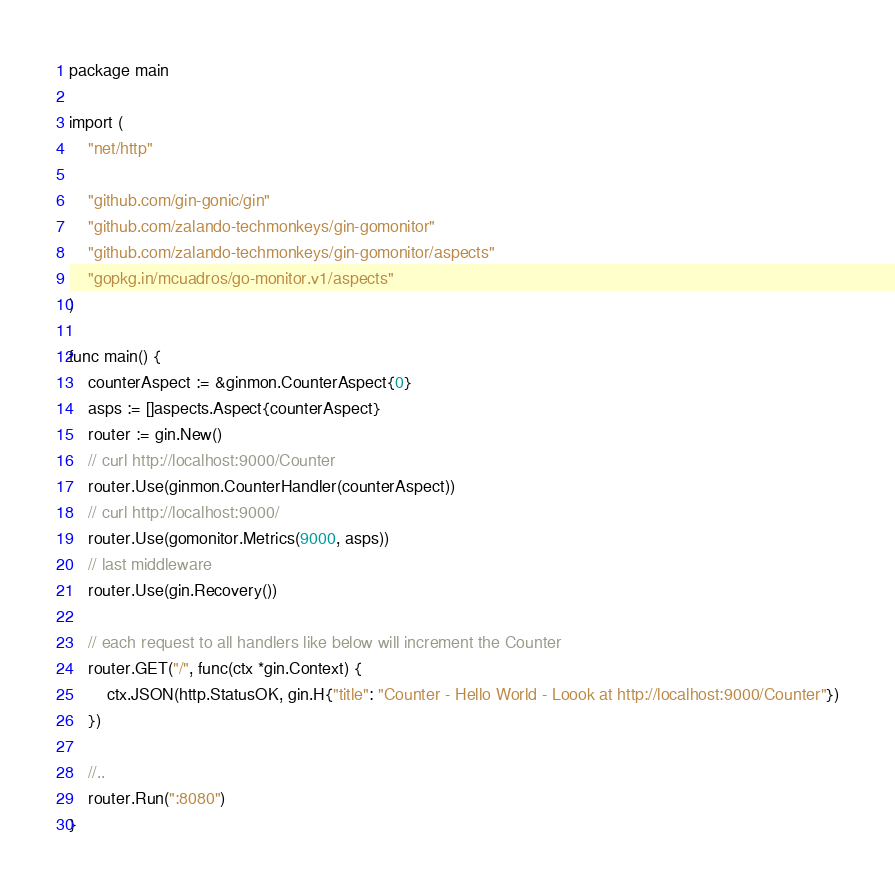Convert code to text. <code><loc_0><loc_0><loc_500><loc_500><_Go_>package main

import (
	"net/http"

	"github.com/gin-gonic/gin"
	"github.com/zalando-techmonkeys/gin-gomonitor"
	"github.com/zalando-techmonkeys/gin-gomonitor/aspects"
	"gopkg.in/mcuadros/go-monitor.v1/aspects"
)

func main() {
	counterAspect := &ginmon.CounterAspect{0}
	asps := []aspects.Aspect{counterAspect}
	router := gin.New()
	// curl http://localhost:9000/Counter
	router.Use(ginmon.CounterHandler(counterAspect))
	// curl http://localhost:9000/
	router.Use(gomonitor.Metrics(9000, asps))
	// last middleware
	router.Use(gin.Recovery())

	// each request to all handlers like below will increment the Counter
	router.GET("/", func(ctx *gin.Context) {
		ctx.JSON(http.StatusOK, gin.H{"title": "Counter - Hello World - Loook at http://localhost:9000/Counter"})
	})

	//..
	router.Run(":8080")
}
</code> 